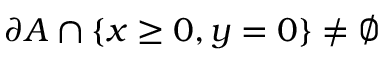Convert formula to latex. <formula><loc_0><loc_0><loc_500><loc_500>\partial A \cap \{ x \geq 0 , y = 0 \} \neq \emptyset</formula> 